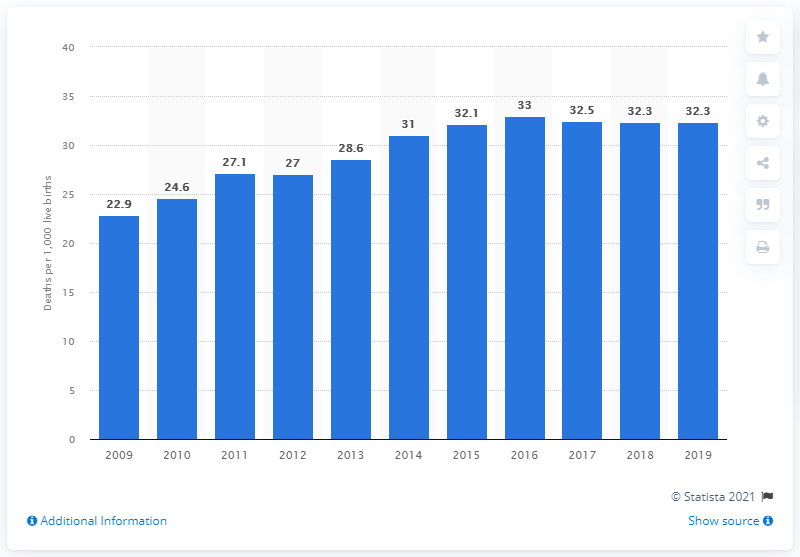List a handful of essential elements in this visual. In 2019, the infant mortality rate in Botswana was 32.3 deaths per 1,000 live births. 